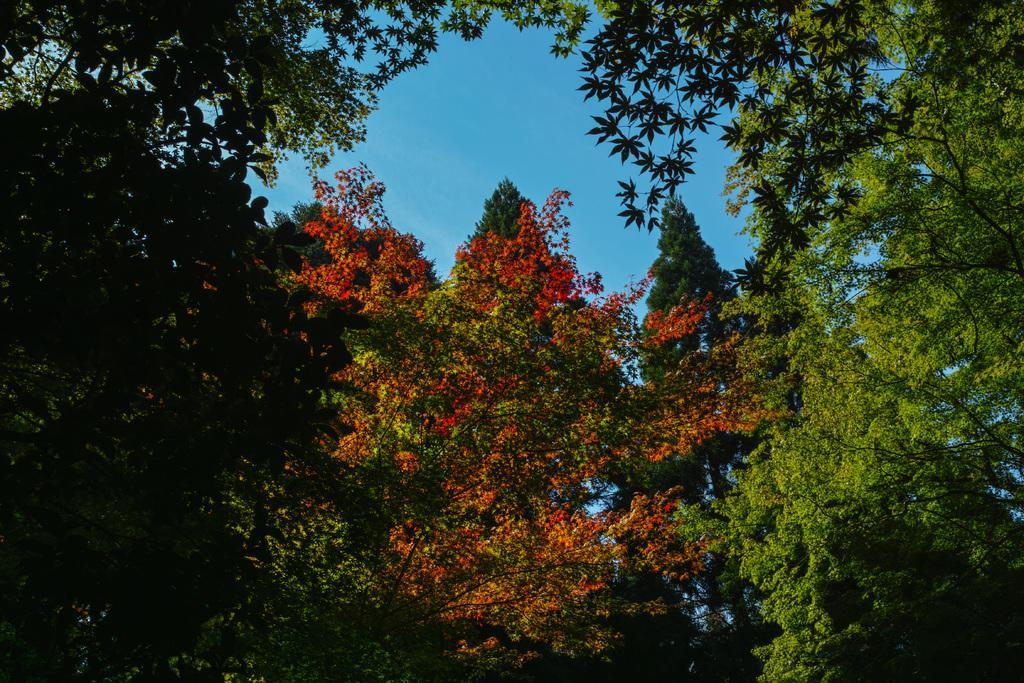Can you describe this image briefly? In this image, we can see trees. Background there is the sky. 